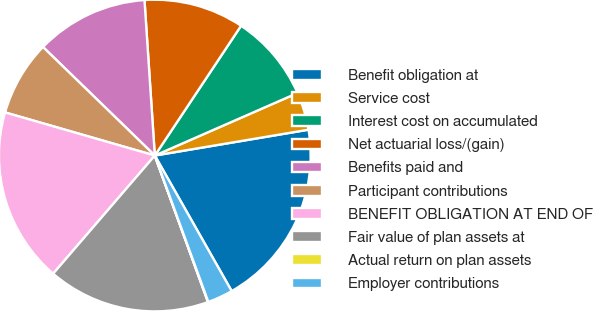<chart> <loc_0><loc_0><loc_500><loc_500><pie_chart><fcel>Benefit obligation at<fcel>Service cost<fcel>Interest cost on accumulated<fcel>Net actuarial loss/(gain)<fcel>Benefits paid and<fcel>Participant contributions<fcel>BENEFIT OBLIGATION AT END OF<fcel>Fair value of plan assets at<fcel>Actual return on plan assets<fcel>Employer contributions<nl><fcel>19.44%<fcel>3.92%<fcel>9.09%<fcel>10.39%<fcel>11.68%<fcel>7.8%<fcel>18.15%<fcel>16.85%<fcel>0.04%<fcel>2.63%<nl></chart> 